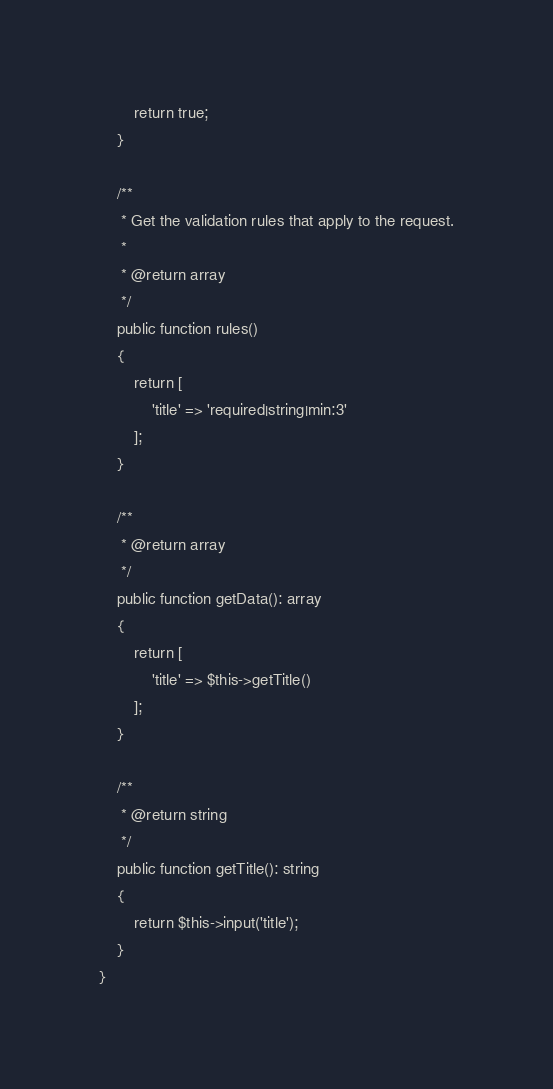<code> <loc_0><loc_0><loc_500><loc_500><_PHP_>        return true;
    }

    /**
     * Get the validation rules that apply to the request.
     *
     * @return array
     */
    public function rules()
    {
        return [
            'title' => 'required|string|min:3'
        ];
    }

    /**
     * @return array
     */
    public function getData(): array
    {
        return [
            'title' => $this->getTitle()
        ];
    }

    /**
     * @return string
     */
    public function getTitle(): string
    {
        return $this->input('title');
    }
}
</code> 